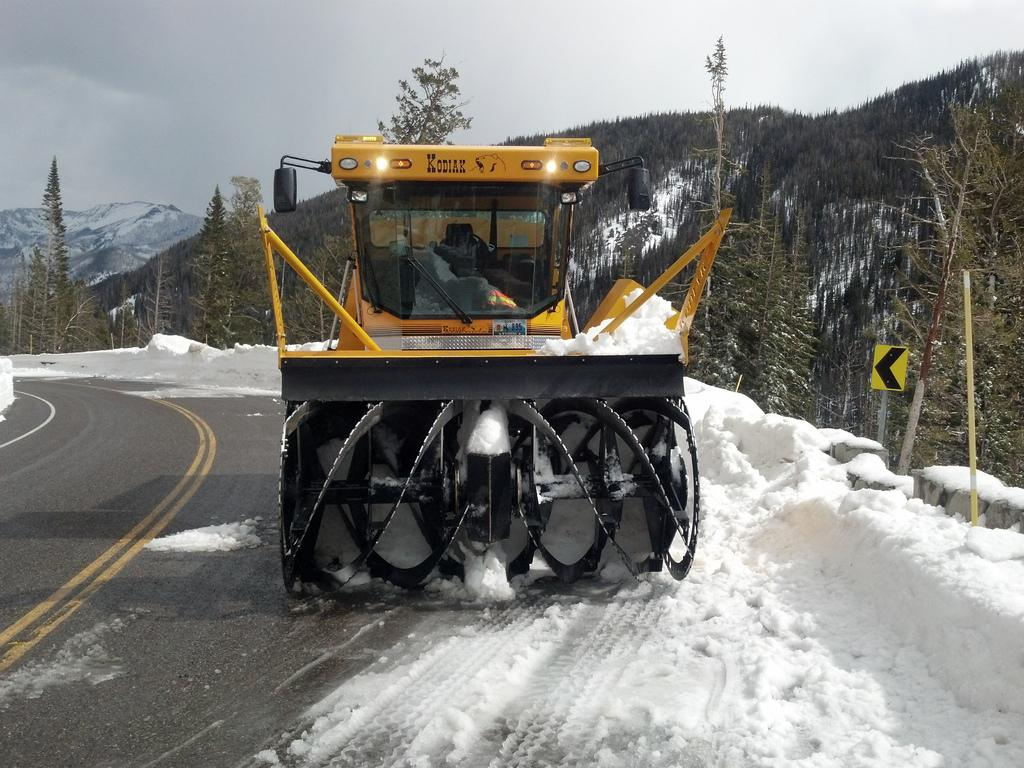What is located in the foreground of the image? There is a vehicle and snow in the foreground of the image. What can be seen in the background of the image? There are trees and mountains in the background of the image. What is at the bottom of the image? There is a road at the bottom of the image. What is visible at the top of the image? There is a sky at the top of the image. Can you tell me how many umbrellas are open in the image? There are no umbrellas present in the image. What type of air is depicted in the image? The image does not depict any specific type of air; it simply shows a sky. 